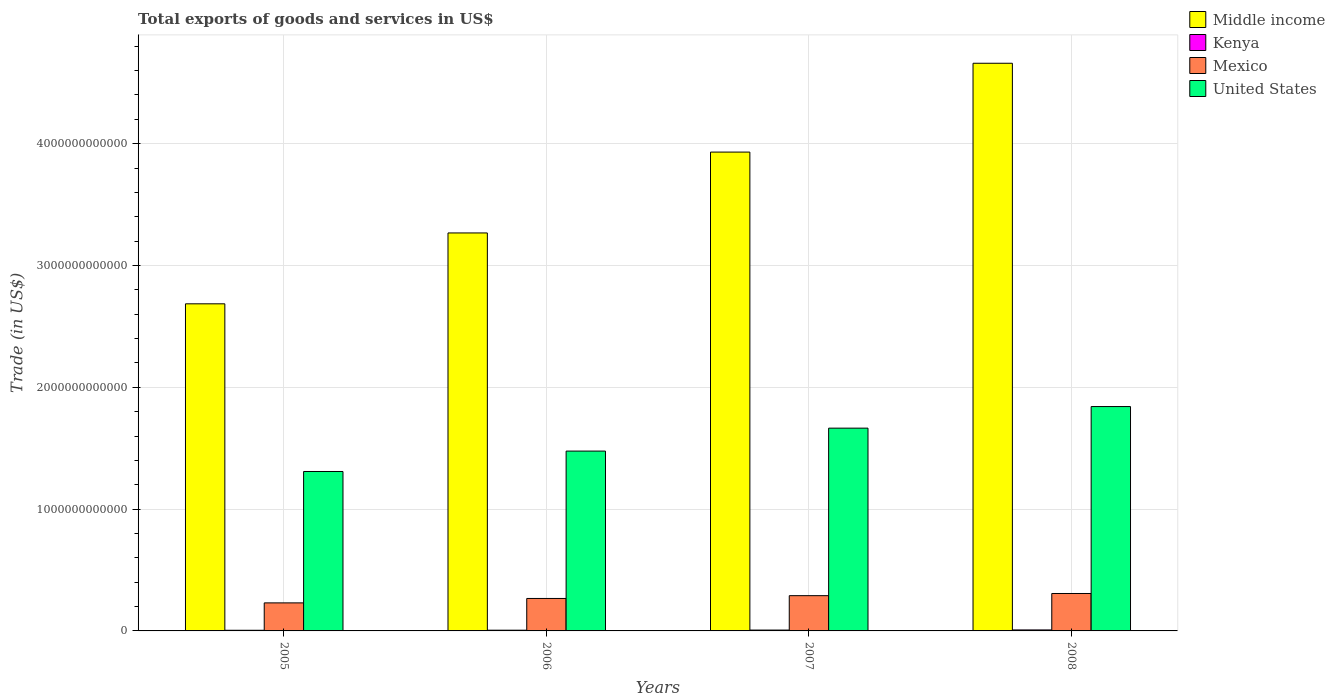How many different coloured bars are there?
Provide a succinct answer. 4. Are the number of bars per tick equal to the number of legend labels?
Keep it short and to the point. Yes. Are the number of bars on each tick of the X-axis equal?
Give a very brief answer. Yes. In how many cases, is the number of bars for a given year not equal to the number of legend labels?
Give a very brief answer. 0. What is the total exports of goods and services in Kenya in 2006?
Offer a terse response. 5.94e+09. Across all years, what is the maximum total exports of goods and services in United States?
Your answer should be compact. 1.84e+12. Across all years, what is the minimum total exports of goods and services in Middle income?
Your answer should be compact. 2.69e+12. In which year was the total exports of goods and services in Middle income maximum?
Your answer should be compact. 2008. What is the total total exports of goods and services in Mexico in the graph?
Your answer should be compact. 1.09e+12. What is the difference between the total exports of goods and services in Middle income in 2006 and that in 2007?
Give a very brief answer. -6.64e+11. What is the difference between the total exports of goods and services in United States in 2007 and the total exports of goods and services in Middle income in 2006?
Ensure brevity in your answer.  -1.60e+12. What is the average total exports of goods and services in Middle income per year?
Make the answer very short. 3.64e+12. In the year 2005, what is the difference between the total exports of goods and services in Kenya and total exports of goods and services in Mexico?
Give a very brief answer. -2.25e+11. What is the ratio of the total exports of goods and services in Kenya in 2007 to that in 2008?
Give a very brief answer. 0.86. What is the difference between the highest and the second highest total exports of goods and services in Kenya?
Provide a succinct answer. 1.13e+09. What is the difference between the highest and the lowest total exports of goods and services in Kenya?
Give a very brief answer. 2.80e+09. Is the sum of the total exports of goods and services in Middle income in 2006 and 2008 greater than the maximum total exports of goods and services in Kenya across all years?
Offer a very short reply. Yes. Is it the case that in every year, the sum of the total exports of goods and services in United States and total exports of goods and services in Kenya is greater than the sum of total exports of goods and services in Mexico and total exports of goods and services in Middle income?
Offer a very short reply. Yes. What does the 1st bar from the left in 2007 represents?
Offer a terse response. Middle income. What does the 3rd bar from the right in 2006 represents?
Offer a terse response. Kenya. Is it the case that in every year, the sum of the total exports of goods and services in Kenya and total exports of goods and services in United States is greater than the total exports of goods and services in Mexico?
Your response must be concise. Yes. How many bars are there?
Provide a succinct answer. 16. What is the difference between two consecutive major ticks on the Y-axis?
Your answer should be very brief. 1.00e+12. Are the values on the major ticks of Y-axis written in scientific E-notation?
Your answer should be compact. No. Where does the legend appear in the graph?
Keep it short and to the point. Top right. How are the legend labels stacked?
Your answer should be very brief. Vertical. What is the title of the graph?
Ensure brevity in your answer.  Total exports of goods and services in US$. What is the label or title of the X-axis?
Your answer should be very brief. Years. What is the label or title of the Y-axis?
Your answer should be very brief. Trade (in US$). What is the Trade (in US$) in Middle income in 2005?
Offer a terse response. 2.69e+12. What is the Trade (in US$) in Kenya in 2005?
Offer a very short reply. 5.34e+09. What is the Trade (in US$) of Mexico in 2005?
Offer a terse response. 2.30e+11. What is the Trade (in US$) in United States in 2005?
Your answer should be very brief. 1.31e+12. What is the Trade (in US$) in Middle income in 2006?
Provide a succinct answer. 3.27e+12. What is the Trade (in US$) in Kenya in 2006?
Make the answer very short. 5.94e+09. What is the Trade (in US$) in Mexico in 2006?
Give a very brief answer. 2.66e+11. What is the Trade (in US$) in United States in 2006?
Make the answer very short. 1.48e+12. What is the Trade (in US$) of Middle income in 2007?
Your answer should be compact. 3.93e+12. What is the Trade (in US$) of Kenya in 2007?
Your answer should be very brief. 7.00e+09. What is the Trade (in US$) in Mexico in 2007?
Your answer should be compact. 2.89e+11. What is the Trade (in US$) in United States in 2007?
Your answer should be compact. 1.66e+12. What is the Trade (in US$) in Middle income in 2008?
Your answer should be very brief. 4.66e+12. What is the Trade (in US$) in Kenya in 2008?
Your response must be concise. 8.14e+09. What is the Trade (in US$) in Mexico in 2008?
Provide a short and direct response. 3.07e+11. What is the Trade (in US$) of United States in 2008?
Make the answer very short. 1.84e+12. Across all years, what is the maximum Trade (in US$) of Middle income?
Make the answer very short. 4.66e+12. Across all years, what is the maximum Trade (in US$) in Kenya?
Your answer should be very brief. 8.14e+09. Across all years, what is the maximum Trade (in US$) of Mexico?
Offer a very short reply. 3.07e+11. Across all years, what is the maximum Trade (in US$) of United States?
Provide a short and direct response. 1.84e+12. Across all years, what is the minimum Trade (in US$) in Middle income?
Give a very brief answer. 2.69e+12. Across all years, what is the minimum Trade (in US$) of Kenya?
Give a very brief answer. 5.34e+09. Across all years, what is the minimum Trade (in US$) of Mexico?
Make the answer very short. 2.30e+11. Across all years, what is the minimum Trade (in US$) in United States?
Ensure brevity in your answer.  1.31e+12. What is the total Trade (in US$) in Middle income in the graph?
Give a very brief answer. 1.45e+13. What is the total Trade (in US$) in Kenya in the graph?
Your response must be concise. 2.64e+1. What is the total Trade (in US$) of Mexico in the graph?
Provide a short and direct response. 1.09e+12. What is the total Trade (in US$) of United States in the graph?
Offer a very short reply. 6.29e+12. What is the difference between the Trade (in US$) in Middle income in 2005 and that in 2006?
Your response must be concise. -5.82e+11. What is the difference between the Trade (in US$) of Kenya in 2005 and that in 2006?
Provide a succinct answer. -5.94e+08. What is the difference between the Trade (in US$) in Mexico in 2005 and that in 2006?
Keep it short and to the point. -3.63e+1. What is the difference between the Trade (in US$) of United States in 2005 and that in 2006?
Your answer should be compact. -1.67e+11. What is the difference between the Trade (in US$) in Middle income in 2005 and that in 2007?
Your answer should be very brief. -1.25e+12. What is the difference between the Trade (in US$) in Kenya in 2005 and that in 2007?
Make the answer very short. -1.66e+09. What is the difference between the Trade (in US$) of Mexico in 2005 and that in 2007?
Provide a succinct answer. -5.93e+1. What is the difference between the Trade (in US$) of United States in 2005 and that in 2007?
Provide a short and direct response. -3.56e+11. What is the difference between the Trade (in US$) in Middle income in 2005 and that in 2008?
Your response must be concise. -1.97e+12. What is the difference between the Trade (in US$) in Kenya in 2005 and that in 2008?
Provide a succinct answer. -2.80e+09. What is the difference between the Trade (in US$) in Mexico in 2005 and that in 2008?
Your answer should be very brief. -7.71e+1. What is the difference between the Trade (in US$) in United States in 2005 and that in 2008?
Your response must be concise. -5.33e+11. What is the difference between the Trade (in US$) of Middle income in 2006 and that in 2007?
Give a very brief answer. -6.64e+11. What is the difference between the Trade (in US$) of Kenya in 2006 and that in 2007?
Ensure brevity in your answer.  -1.07e+09. What is the difference between the Trade (in US$) of Mexico in 2006 and that in 2007?
Your answer should be compact. -2.30e+1. What is the difference between the Trade (in US$) in United States in 2006 and that in 2007?
Offer a terse response. -1.88e+11. What is the difference between the Trade (in US$) in Middle income in 2006 and that in 2008?
Your response must be concise. -1.39e+12. What is the difference between the Trade (in US$) in Kenya in 2006 and that in 2008?
Make the answer very short. -2.20e+09. What is the difference between the Trade (in US$) in Mexico in 2006 and that in 2008?
Offer a very short reply. -4.08e+1. What is the difference between the Trade (in US$) of United States in 2006 and that in 2008?
Provide a succinct answer. -3.66e+11. What is the difference between the Trade (in US$) in Middle income in 2007 and that in 2008?
Your answer should be compact. -7.29e+11. What is the difference between the Trade (in US$) in Kenya in 2007 and that in 2008?
Provide a succinct answer. -1.13e+09. What is the difference between the Trade (in US$) of Mexico in 2007 and that in 2008?
Offer a terse response. -1.78e+1. What is the difference between the Trade (in US$) in United States in 2007 and that in 2008?
Offer a very short reply. -1.77e+11. What is the difference between the Trade (in US$) of Middle income in 2005 and the Trade (in US$) of Kenya in 2006?
Your response must be concise. 2.68e+12. What is the difference between the Trade (in US$) of Middle income in 2005 and the Trade (in US$) of Mexico in 2006?
Ensure brevity in your answer.  2.42e+12. What is the difference between the Trade (in US$) in Middle income in 2005 and the Trade (in US$) in United States in 2006?
Keep it short and to the point. 1.21e+12. What is the difference between the Trade (in US$) in Kenya in 2005 and the Trade (in US$) in Mexico in 2006?
Keep it short and to the point. -2.61e+11. What is the difference between the Trade (in US$) in Kenya in 2005 and the Trade (in US$) in United States in 2006?
Your response must be concise. -1.47e+12. What is the difference between the Trade (in US$) of Mexico in 2005 and the Trade (in US$) of United States in 2006?
Make the answer very short. -1.25e+12. What is the difference between the Trade (in US$) of Middle income in 2005 and the Trade (in US$) of Kenya in 2007?
Your response must be concise. 2.68e+12. What is the difference between the Trade (in US$) in Middle income in 2005 and the Trade (in US$) in Mexico in 2007?
Give a very brief answer. 2.40e+12. What is the difference between the Trade (in US$) in Middle income in 2005 and the Trade (in US$) in United States in 2007?
Your answer should be compact. 1.02e+12. What is the difference between the Trade (in US$) in Kenya in 2005 and the Trade (in US$) in Mexico in 2007?
Make the answer very short. -2.84e+11. What is the difference between the Trade (in US$) of Kenya in 2005 and the Trade (in US$) of United States in 2007?
Your answer should be compact. -1.66e+12. What is the difference between the Trade (in US$) of Mexico in 2005 and the Trade (in US$) of United States in 2007?
Offer a very short reply. -1.43e+12. What is the difference between the Trade (in US$) of Middle income in 2005 and the Trade (in US$) of Kenya in 2008?
Offer a very short reply. 2.68e+12. What is the difference between the Trade (in US$) in Middle income in 2005 and the Trade (in US$) in Mexico in 2008?
Keep it short and to the point. 2.38e+12. What is the difference between the Trade (in US$) in Middle income in 2005 and the Trade (in US$) in United States in 2008?
Provide a short and direct response. 8.43e+11. What is the difference between the Trade (in US$) in Kenya in 2005 and the Trade (in US$) in Mexico in 2008?
Offer a terse response. -3.02e+11. What is the difference between the Trade (in US$) of Kenya in 2005 and the Trade (in US$) of United States in 2008?
Make the answer very short. -1.84e+12. What is the difference between the Trade (in US$) in Mexico in 2005 and the Trade (in US$) in United States in 2008?
Your answer should be very brief. -1.61e+12. What is the difference between the Trade (in US$) in Middle income in 2006 and the Trade (in US$) in Kenya in 2007?
Give a very brief answer. 3.26e+12. What is the difference between the Trade (in US$) in Middle income in 2006 and the Trade (in US$) in Mexico in 2007?
Ensure brevity in your answer.  2.98e+12. What is the difference between the Trade (in US$) in Middle income in 2006 and the Trade (in US$) in United States in 2007?
Offer a very short reply. 1.60e+12. What is the difference between the Trade (in US$) in Kenya in 2006 and the Trade (in US$) in Mexico in 2007?
Your answer should be very brief. -2.84e+11. What is the difference between the Trade (in US$) in Kenya in 2006 and the Trade (in US$) in United States in 2007?
Give a very brief answer. -1.66e+12. What is the difference between the Trade (in US$) in Mexico in 2006 and the Trade (in US$) in United States in 2007?
Offer a very short reply. -1.40e+12. What is the difference between the Trade (in US$) of Middle income in 2006 and the Trade (in US$) of Kenya in 2008?
Provide a succinct answer. 3.26e+12. What is the difference between the Trade (in US$) of Middle income in 2006 and the Trade (in US$) of Mexico in 2008?
Your answer should be very brief. 2.96e+12. What is the difference between the Trade (in US$) in Middle income in 2006 and the Trade (in US$) in United States in 2008?
Provide a short and direct response. 1.43e+12. What is the difference between the Trade (in US$) in Kenya in 2006 and the Trade (in US$) in Mexico in 2008?
Make the answer very short. -3.01e+11. What is the difference between the Trade (in US$) of Kenya in 2006 and the Trade (in US$) of United States in 2008?
Make the answer very short. -1.84e+12. What is the difference between the Trade (in US$) in Mexico in 2006 and the Trade (in US$) in United States in 2008?
Your response must be concise. -1.58e+12. What is the difference between the Trade (in US$) in Middle income in 2007 and the Trade (in US$) in Kenya in 2008?
Your answer should be compact. 3.92e+12. What is the difference between the Trade (in US$) in Middle income in 2007 and the Trade (in US$) in Mexico in 2008?
Your answer should be very brief. 3.62e+12. What is the difference between the Trade (in US$) of Middle income in 2007 and the Trade (in US$) of United States in 2008?
Your answer should be very brief. 2.09e+12. What is the difference between the Trade (in US$) in Kenya in 2007 and the Trade (in US$) in Mexico in 2008?
Your response must be concise. -3.00e+11. What is the difference between the Trade (in US$) in Kenya in 2007 and the Trade (in US$) in United States in 2008?
Your response must be concise. -1.83e+12. What is the difference between the Trade (in US$) of Mexico in 2007 and the Trade (in US$) of United States in 2008?
Make the answer very short. -1.55e+12. What is the average Trade (in US$) of Middle income per year?
Offer a terse response. 3.64e+12. What is the average Trade (in US$) of Kenya per year?
Offer a terse response. 6.61e+09. What is the average Trade (in US$) in Mexico per year?
Provide a short and direct response. 2.73e+11. What is the average Trade (in US$) of United States per year?
Your response must be concise. 1.57e+12. In the year 2005, what is the difference between the Trade (in US$) of Middle income and Trade (in US$) of Kenya?
Give a very brief answer. 2.68e+12. In the year 2005, what is the difference between the Trade (in US$) of Middle income and Trade (in US$) of Mexico?
Your answer should be very brief. 2.46e+12. In the year 2005, what is the difference between the Trade (in US$) in Middle income and Trade (in US$) in United States?
Your response must be concise. 1.38e+12. In the year 2005, what is the difference between the Trade (in US$) of Kenya and Trade (in US$) of Mexico?
Give a very brief answer. -2.25e+11. In the year 2005, what is the difference between the Trade (in US$) of Kenya and Trade (in US$) of United States?
Give a very brief answer. -1.30e+12. In the year 2005, what is the difference between the Trade (in US$) of Mexico and Trade (in US$) of United States?
Ensure brevity in your answer.  -1.08e+12. In the year 2006, what is the difference between the Trade (in US$) of Middle income and Trade (in US$) of Kenya?
Your answer should be compact. 3.26e+12. In the year 2006, what is the difference between the Trade (in US$) of Middle income and Trade (in US$) of Mexico?
Ensure brevity in your answer.  3.00e+12. In the year 2006, what is the difference between the Trade (in US$) in Middle income and Trade (in US$) in United States?
Provide a succinct answer. 1.79e+12. In the year 2006, what is the difference between the Trade (in US$) in Kenya and Trade (in US$) in Mexico?
Ensure brevity in your answer.  -2.60e+11. In the year 2006, what is the difference between the Trade (in US$) in Kenya and Trade (in US$) in United States?
Your response must be concise. -1.47e+12. In the year 2006, what is the difference between the Trade (in US$) in Mexico and Trade (in US$) in United States?
Your answer should be very brief. -1.21e+12. In the year 2007, what is the difference between the Trade (in US$) of Middle income and Trade (in US$) of Kenya?
Ensure brevity in your answer.  3.92e+12. In the year 2007, what is the difference between the Trade (in US$) of Middle income and Trade (in US$) of Mexico?
Ensure brevity in your answer.  3.64e+12. In the year 2007, what is the difference between the Trade (in US$) of Middle income and Trade (in US$) of United States?
Provide a succinct answer. 2.27e+12. In the year 2007, what is the difference between the Trade (in US$) in Kenya and Trade (in US$) in Mexico?
Your answer should be compact. -2.82e+11. In the year 2007, what is the difference between the Trade (in US$) in Kenya and Trade (in US$) in United States?
Offer a terse response. -1.66e+12. In the year 2007, what is the difference between the Trade (in US$) of Mexico and Trade (in US$) of United States?
Ensure brevity in your answer.  -1.38e+12. In the year 2008, what is the difference between the Trade (in US$) of Middle income and Trade (in US$) of Kenya?
Offer a very short reply. 4.65e+12. In the year 2008, what is the difference between the Trade (in US$) of Middle income and Trade (in US$) of Mexico?
Offer a very short reply. 4.35e+12. In the year 2008, what is the difference between the Trade (in US$) in Middle income and Trade (in US$) in United States?
Give a very brief answer. 2.82e+12. In the year 2008, what is the difference between the Trade (in US$) of Kenya and Trade (in US$) of Mexico?
Offer a terse response. -2.99e+11. In the year 2008, what is the difference between the Trade (in US$) of Kenya and Trade (in US$) of United States?
Keep it short and to the point. -1.83e+12. In the year 2008, what is the difference between the Trade (in US$) of Mexico and Trade (in US$) of United States?
Make the answer very short. -1.53e+12. What is the ratio of the Trade (in US$) of Middle income in 2005 to that in 2006?
Your answer should be compact. 0.82. What is the ratio of the Trade (in US$) in Kenya in 2005 to that in 2006?
Make the answer very short. 0.9. What is the ratio of the Trade (in US$) in Mexico in 2005 to that in 2006?
Give a very brief answer. 0.86. What is the ratio of the Trade (in US$) in United States in 2005 to that in 2006?
Ensure brevity in your answer.  0.89. What is the ratio of the Trade (in US$) of Middle income in 2005 to that in 2007?
Make the answer very short. 0.68. What is the ratio of the Trade (in US$) of Kenya in 2005 to that in 2007?
Offer a terse response. 0.76. What is the ratio of the Trade (in US$) in Mexico in 2005 to that in 2007?
Your answer should be very brief. 0.8. What is the ratio of the Trade (in US$) of United States in 2005 to that in 2007?
Provide a short and direct response. 0.79. What is the ratio of the Trade (in US$) of Middle income in 2005 to that in 2008?
Give a very brief answer. 0.58. What is the ratio of the Trade (in US$) of Kenya in 2005 to that in 2008?
Provide a succinct answer. 0.66. What is the ratio of the Trade (in US$) in Mexico in 2005 to that in 2008?
Your answer should be very brief. 0.75. What is the ratio of the Trade (in US$) of United States in 2005 to that in 2008?
Offer a terse response. 0.71. What is the ratio of the Trade (in US$) of Middle income in 2006 to that in 2007?
Keep it short and to the point. 0.83. What is the ratio of the Trade (in US$) in Kenya in 2006 to that in 2007?
Offer a terse response. 0.85. What is the ratio of the Trade (in US$) of Mexico in 2006 to that in 2007?
Offer a terse response. 0.92. What is the ratio of the Trade (in US$) of United States in 2006 to that in 2007?
Your response must be concise. 0.89. What is the ratio of the Trade (in US$) of Middle income in 2006 to that in 2008?
Keep it short and to the point. 0.7. What is the ratio of the Trade (in US$) of Kenya in 2006 to that in 2008?
Provide a short and direct response. 0.73. What is the ratio of the Trade (in US$) in Mexico in 2006 to that in 2008?
Your answer should be very brief. 0.87. What is the ratio of the Trade (in US$) in United States in 2006 to that in 2008?
Offer a very short reply. 0.8. What is the ratio of the Trade (in US$) of Middle income in 2007 to that in 2008?
Offer a terse response. 0.84. What is the ratio of the Trade (in US$) of Kenya in 2007 to that in 2008?
Your response must be concise. 0.86. What is the ratio of the Trade (in US$) of Mexico in 2007 to that in 2008?
Offer a very short reply. 0.94. What is the ratio of the Trade (in US$) of United States in 2007 to that in 2008?
Keep it short and to the point. 0.9. What is the difference between the highest and the second highest Trade (in US$) in Middle income?
Keep it short and to the point. 7.29e+11. What is the difference between the highest and the second highest Trade (in US$) in Kenya?
Your response must be concise. 1.13e+09. What is the difference between the highest and the second highest Trade (in US$) of Mexico?
Provide a succinct answer. 1.78e+1. What is the difference between the highest and the second highest Trade (in US$) of United States?
Offer a terse response. 1.77e+11. What is the difference between the highest and the lowest Trade (in US$) of Middle income?
Ensure brevity in your answer.  1.97e+12. What is the difference between the highest and the lowest Trade (in US$) in Kenya?
Your answer should be compact. 2.80e+09. What is the difference between the highest and the lowest Trade (in US$) in Mexico?
Your answer should be very brief. 7.71e+1. What is the difference between the highest and the lowest Trade (in US$) of United States?
Your answer should be compact. 5.33e+11. 